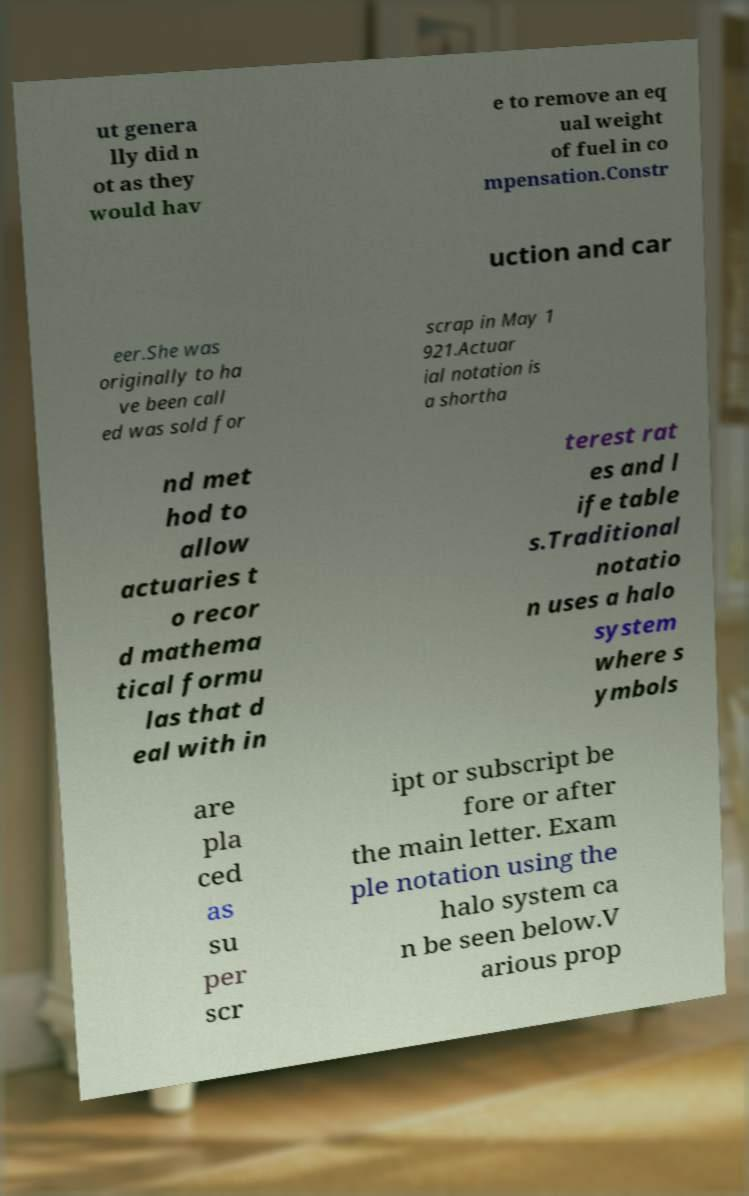I need the written content from this picture converted into text. Can you do that? ut genera lly did n ot as they would hav e to remove an eq ual weight of fuel in co mpensation.Constr uction and car eer.She was originally to ha ve been call ed was sold for scrap in May 1 921.Actuar ial notation is a shortha nd met hod to allow actuaries t o recor d mathema tical formu las that d eal with in terest rat es and l ife table s.Traditional notatio n uses a halo system where s ymbols are pla ced as su per scr ipt or subscript be fore or after the main letter. Exam ple notation using the halo system ca n be seen below.V arious prop 